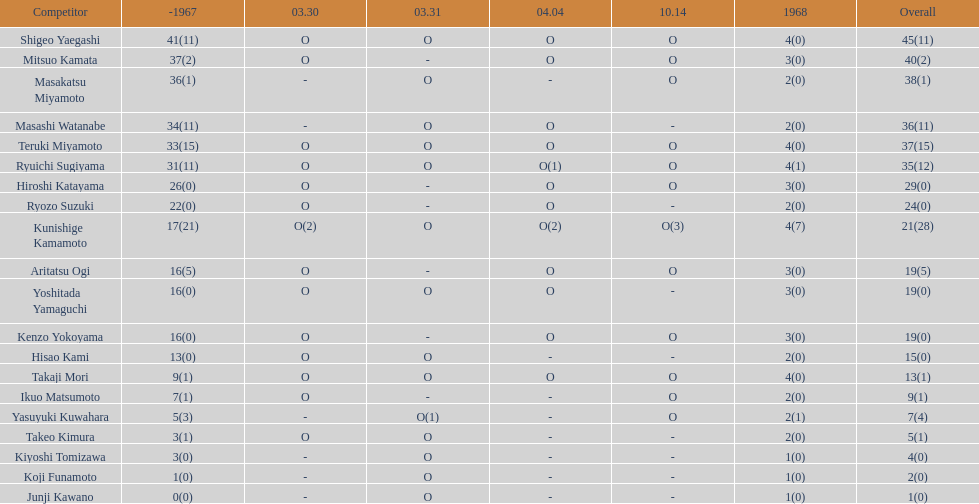Who had more points takaji mori or junji kawano? Takaji Mori. 